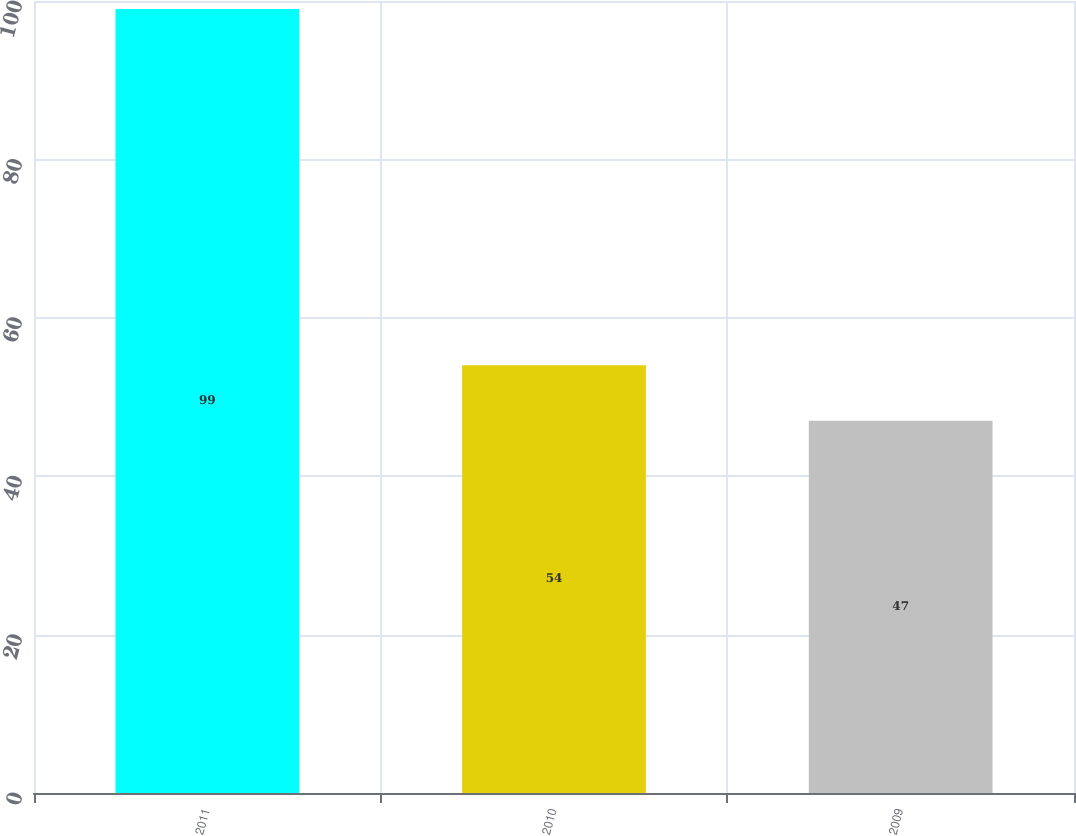Convert chart. <chart><loc_0><loc_0><loc_500><loc_500><bar_chart><fcel>2011<fcel>2010<fcel>2009<nl><fcel>99<fcel>54<fcel>47<nl></chart> 